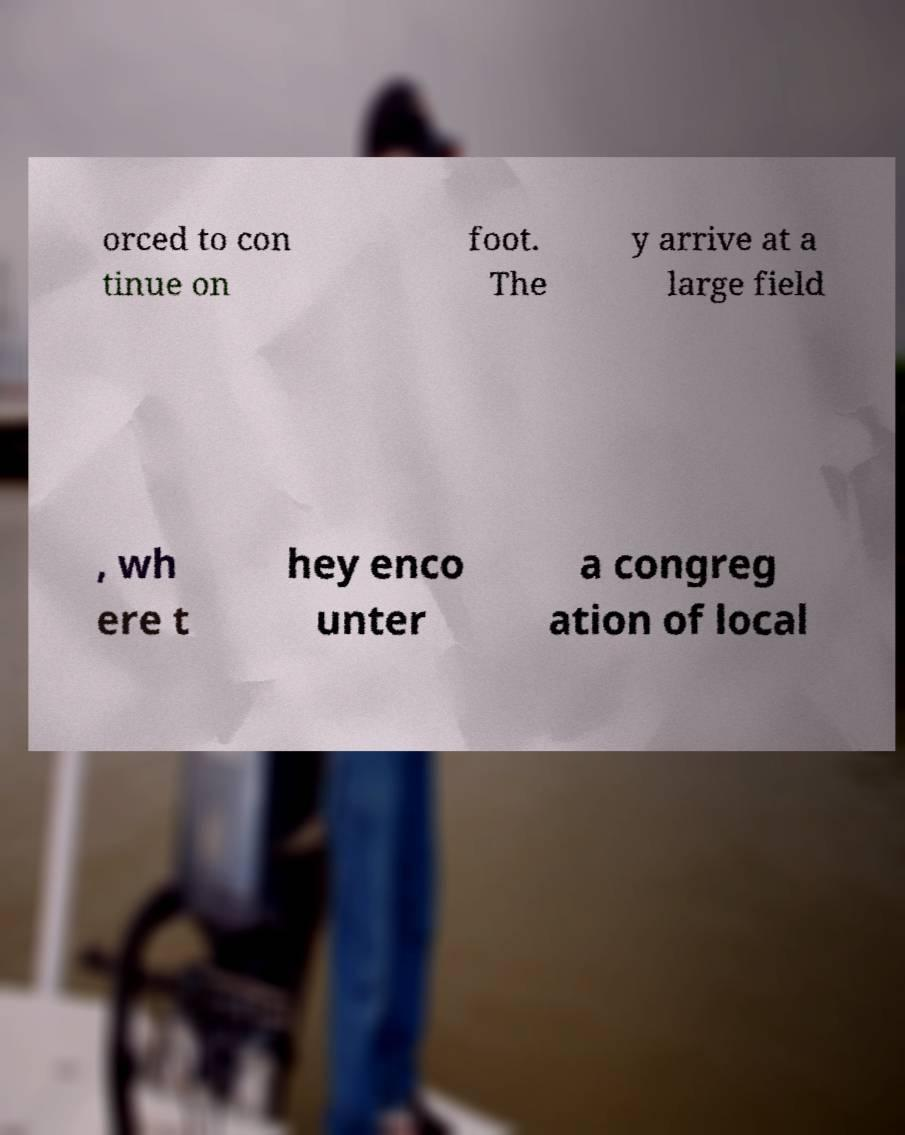For documentation purposes, I need the text within this image transcribed. Could you provide that? orced to con tinue on foot. The y arrive at a large field , wh ere t hey enco unter a congreg ation of local 